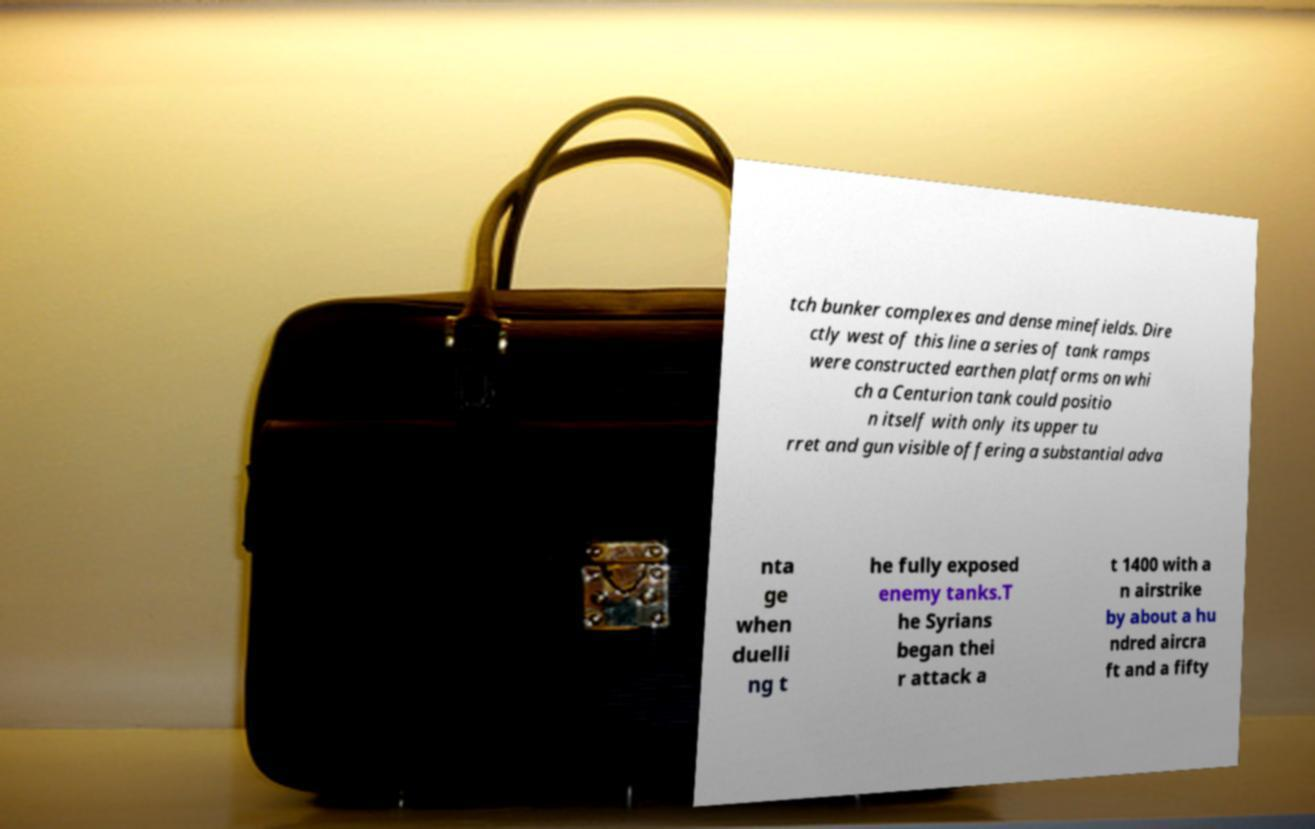Please read and relay the text visible in this image. What does it say? tch bunker complexes and dense minefields. Dire ctly west of this line a series of tank ramps were constructed earthen platforms on whi ch a Centurion tank could positio n itself with only its upper tu rret and gun visible offering a substantial adva nta ge when duelli ng t he fully exposed enemy tanks.T he Syrians began thei r attack a t 1400 with a n airstrike by about a hu ndred aircra ft and a fifty 